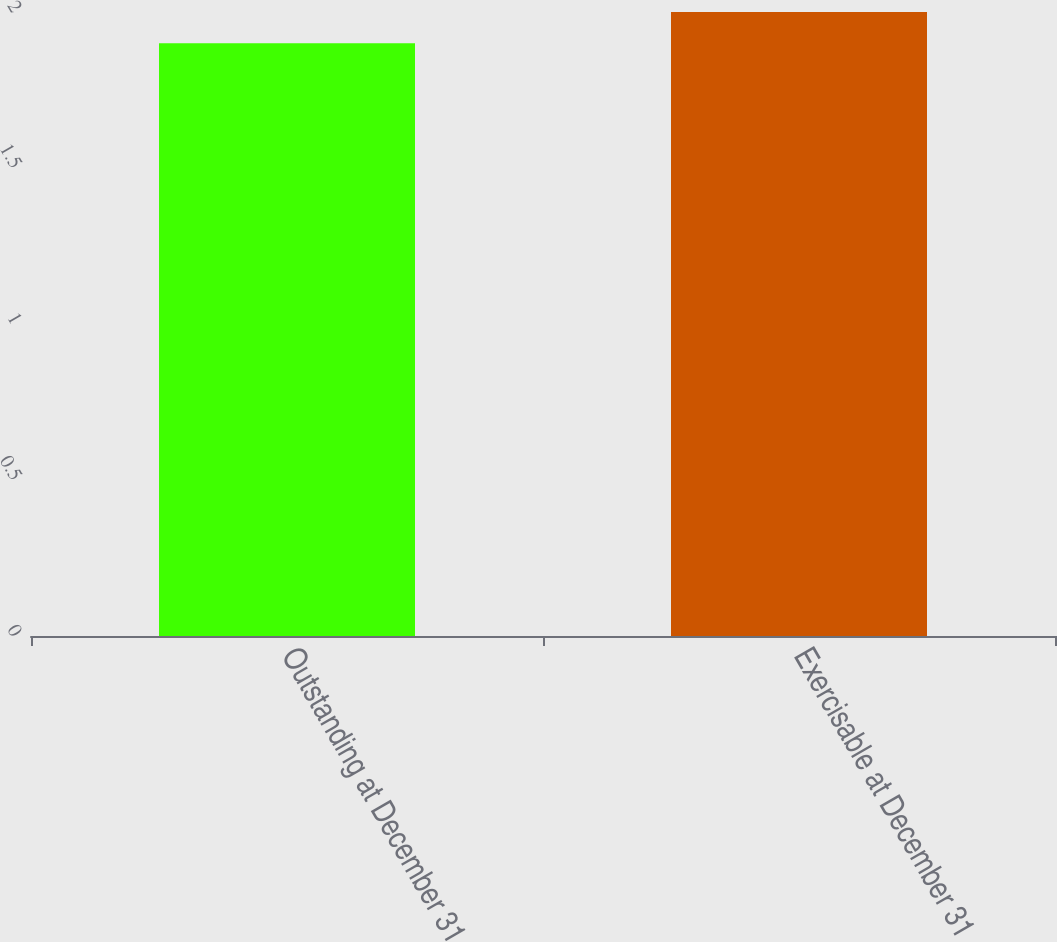Convert chart. <chart><loc_0><loc_0><loc_500><loc_500><bar_chart><fcel>Outstanding at December 31<fcel>Exercisable at December 31<nl><fcel>1.9<fcel>2<nl></chart> 